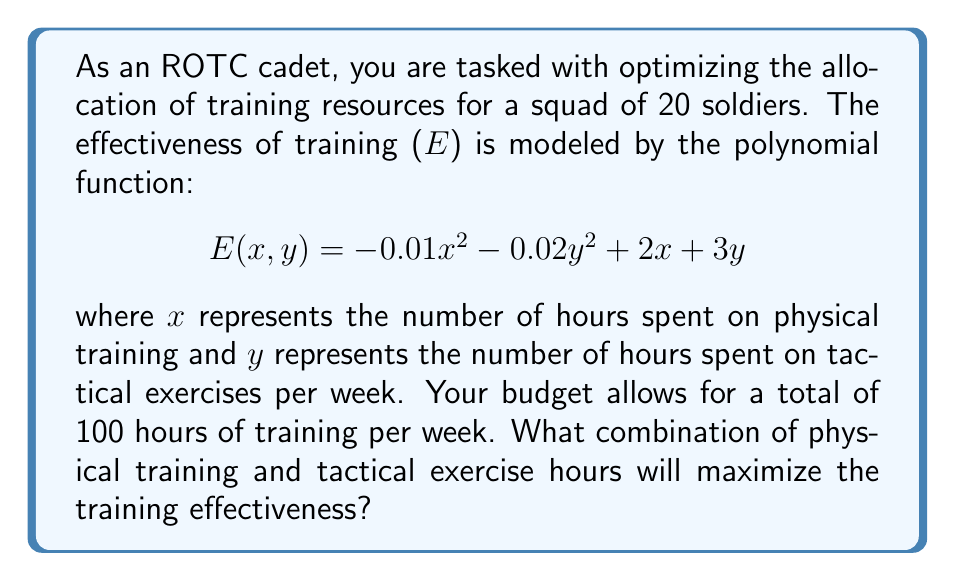Solve this math problem. To solve this optimization problem, we'll use the method of Lagrange multipliers:

1) First, we set up the constraint equation:
   $$x + y = 100$$

2) Now, we form the Lagrangian function:
   $$L(x, y, λ) = E(x, y) - λ(x + y - 100)$$
   $$L(x, y, λ) = -0.01x^2 - 0.02y^2 + 2x + 3y - λ(x + y - 100)$$

3) We find the partial derivatives and set them to zero:
   $$\frac{\partial L}{\partial x} = -0.02x + 2 - λ = 0$$
   $$\frac{\partial L}{\partial y} = -0.04y + 3 - λ = 0$$
   $$\frac{\partial L}{\partial λ} = -(x + y - 100) = 0$$

4) From the first equation:
   $$λ = -0.02x + 2$$

5) From the second equation:
   $$λ = -0.04y + 3$$

6) Equating these:
   $$-0.02x + 2 = -0.04y + 3$$
   $$0.04y = 0.02x + 1$$
   $$2y = x + 50$$

7) Substituting this into the constraint equation:
   $$x + (x + 50)/2 = 100$$
   $$2x + x + 50 = 200$$
   $$3x = 150$$
   $$x = 50$$

8) Then:
   $$y = (50 + 50)/2 = 50$$

9) We can verify this is a maximum by checking the second derivatives.

Therefore, the optimal allocation is 50 hours for physical training and 50 hours for tactical exercises.
Answer: 50 hours physical training, 50 hours tactical exercises 